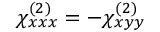<formula> <loc_0><loc_0><loc_500><loc_500>\chi _ { x x x } ^ { ( 2 ) } = - \chi _ { x y y } ^ { ( 2 ) }</formula> 